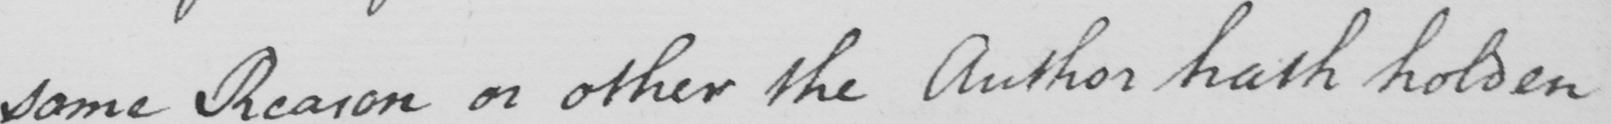What text is written in this handwritten line? some Reason or other the Author hath holden 